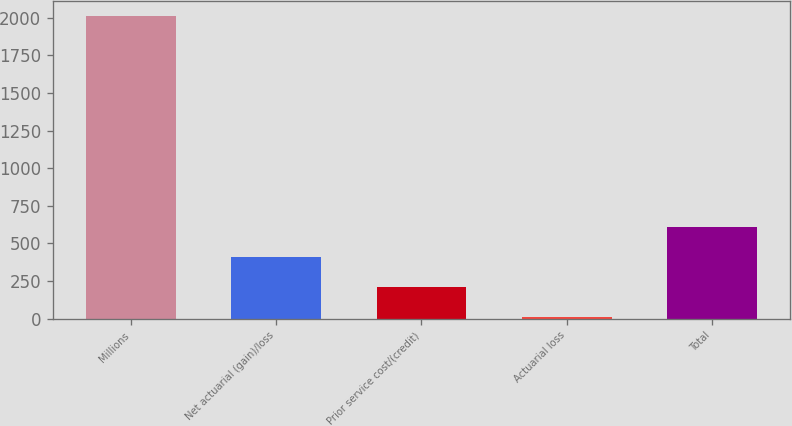<chart> <loc_0><loc_0><loc_500><loc_500><bar_chart><fcel>Millions<fcel>Net actuarial (gain)/loss<fcel>Prior service cost/(credit)<fcel>Actuarial loss<fcel>Total<nl><fcel>2008<fcel>412<fcel>212.5<fcel>13<fcel>611.5<nl></chart> 